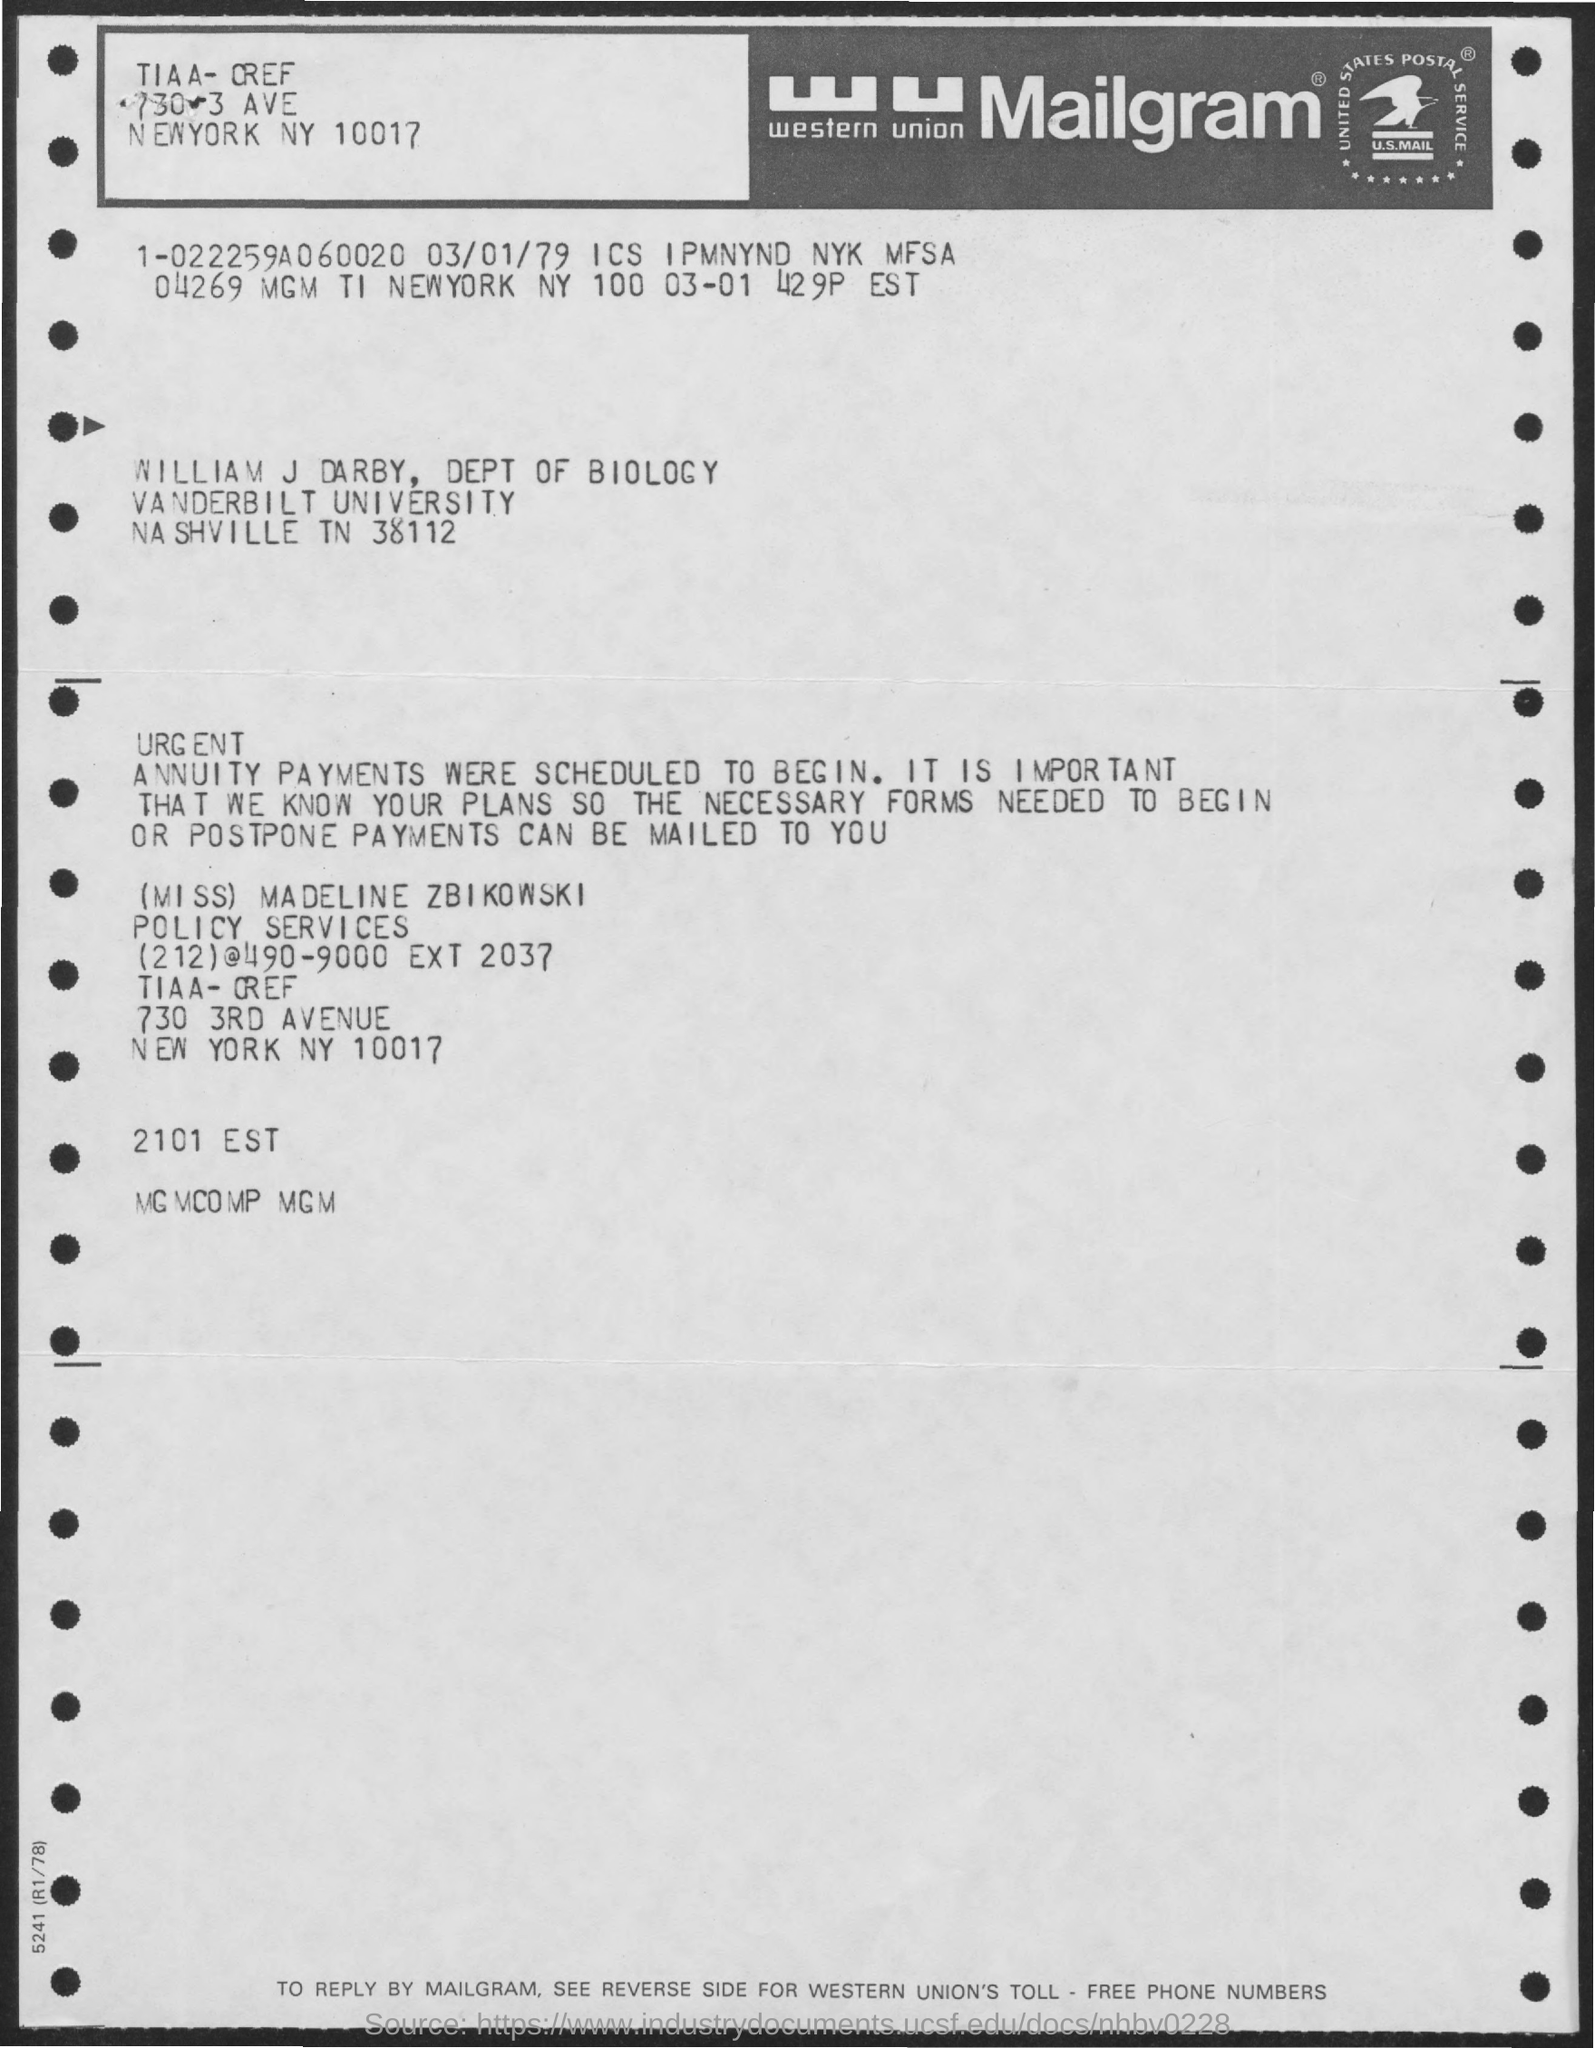List a handful of essential elements in this visual. The letter is addressed to William J Darby. The letter is from a woman named Miss Madeline Zbikowski. 